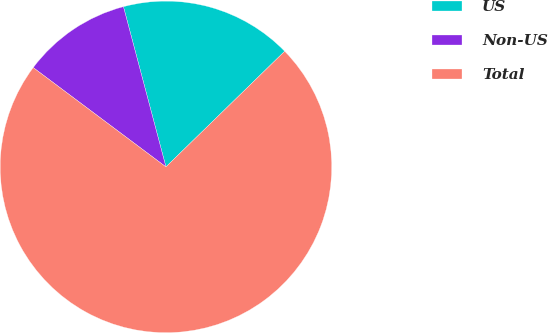Convert chart to OTSL. <chart><loc_0><loc_0><loc_500><loc_500><pie_chart><fcel>US<fcel>Non-US<fcel>Total<nl><fcel>16.84%<fcel>10.65%<fcel>72.52%<nl></chart> 